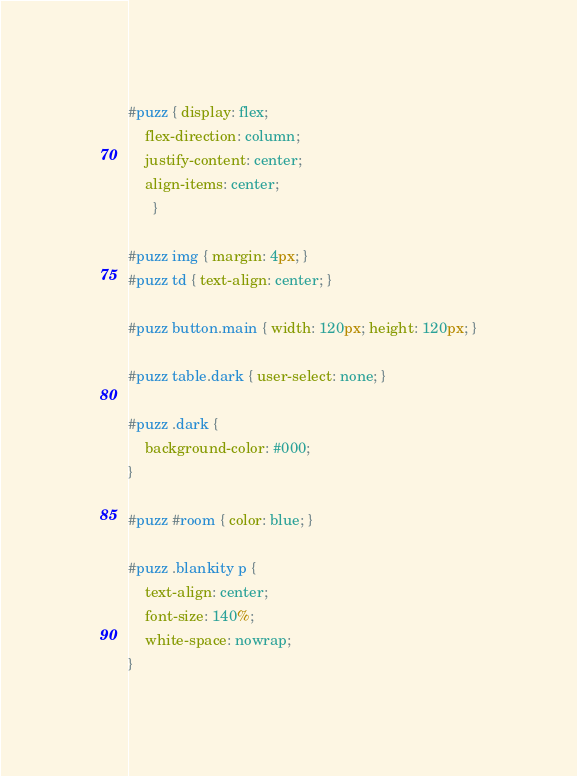Convert code to text. <code><loc_0><loc_0><loc_500><loc_500><_CSS_>#puzz { display: flex;
	flex-direction: column;
	justify-content: center;
	align-items: center;
      }

#puzz img { margin: 4px; }
#puzz td { text-align: center; }

#puzz button.main { width: 120px; height: 120px; }

#puzz table.dark { user-select: none; }

#puzz .dark {
    background-color: #000;
}

#puzz #room { color: blue; }

#puzz .blankity p {
    text-align: center;
    font-size: 140%;
    white-space: nowrap;
}

</code> 